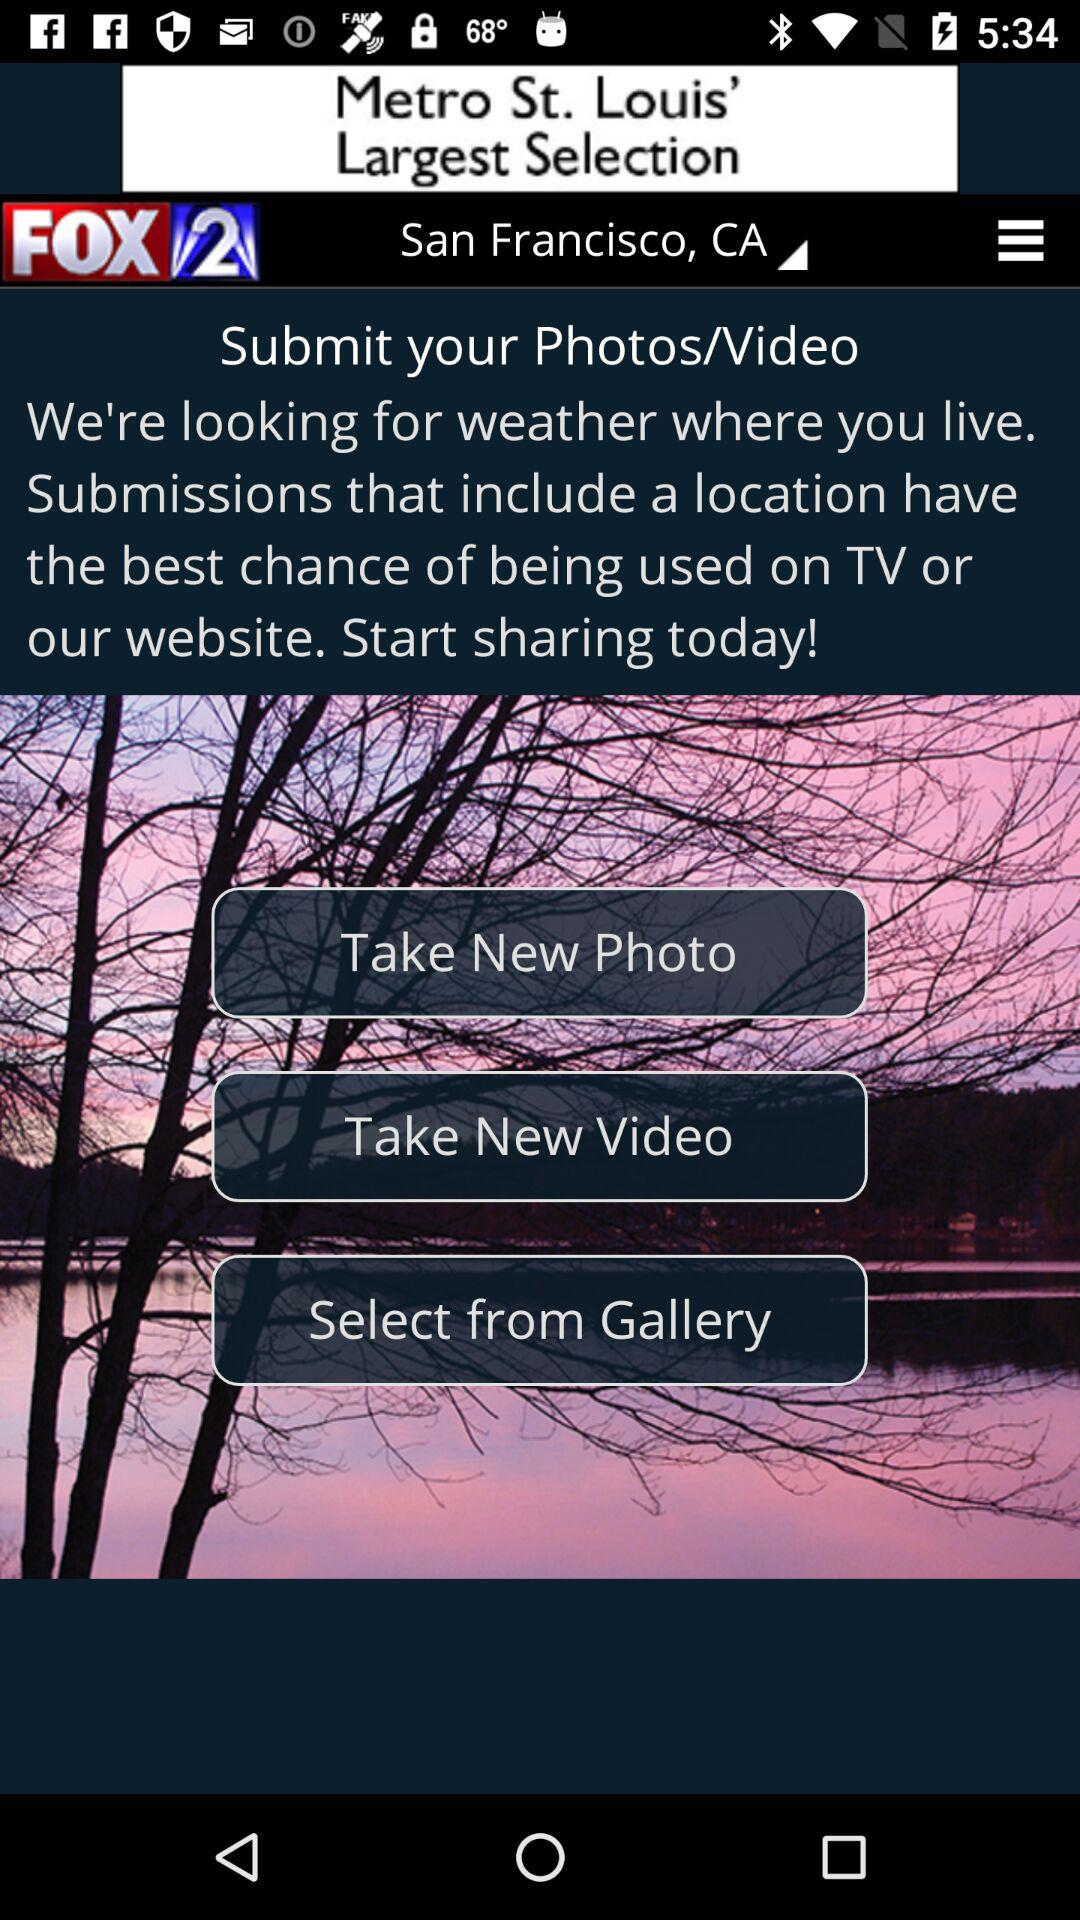Which location is selected? The selected location is San Francisco, CA. 